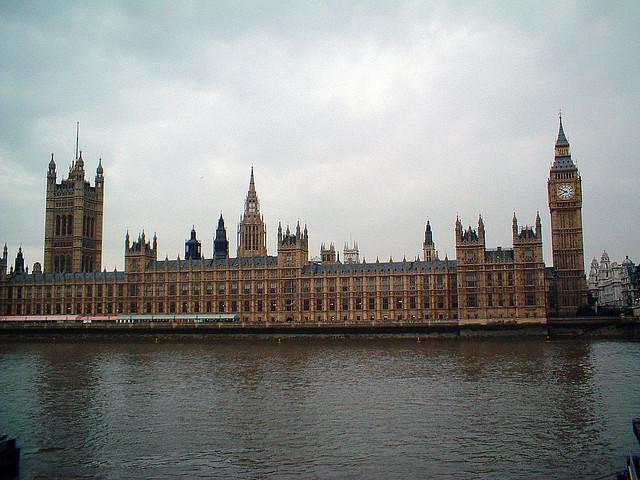Is this at night?
Be succinct. No. Is it a cloudy day?
Short answer required. Yes. Is the water calm?
Give a very brief answer. Yes. What famous landmark is this?
Quick response, please. Big ben. Who big is this landmark?
Quick response, please. Queen. Is this Seattle?
Give a very brief answer. No. 